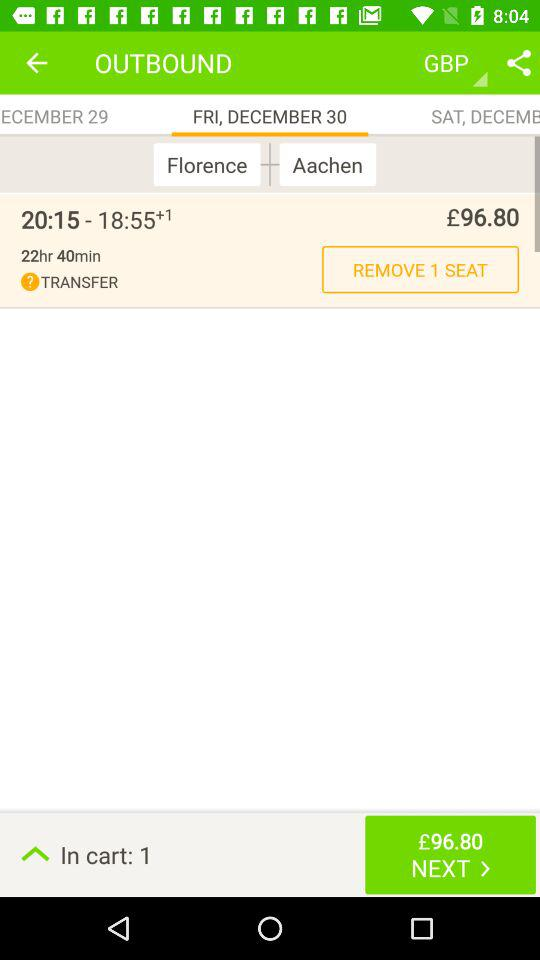What's the duration of the flight? The duration is 22 hours and 40 minutes. 